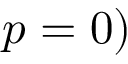<formula> <loc_0><loc_0><loc_500><loc_500>p = 0 )</formula> 